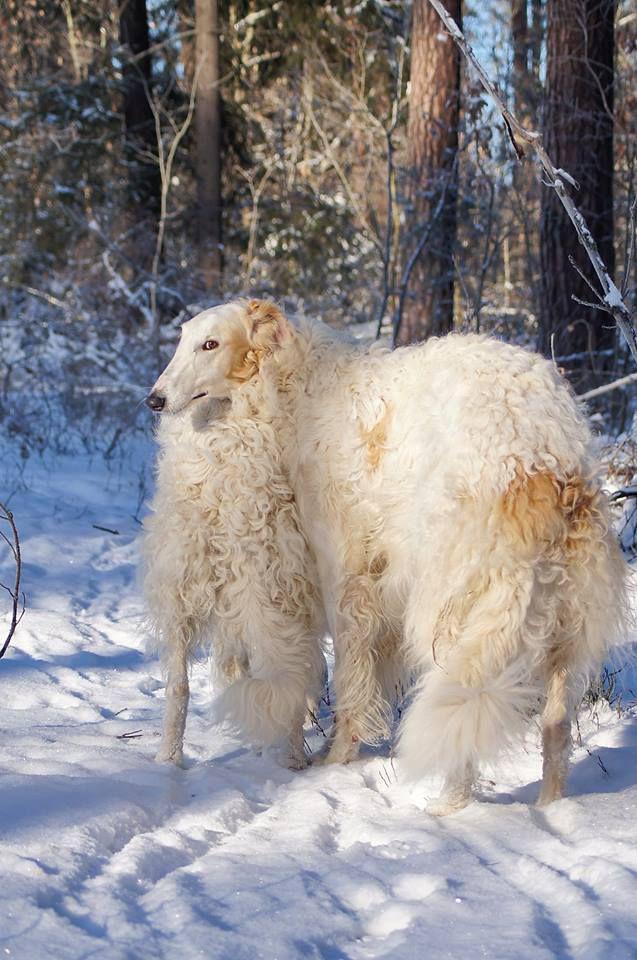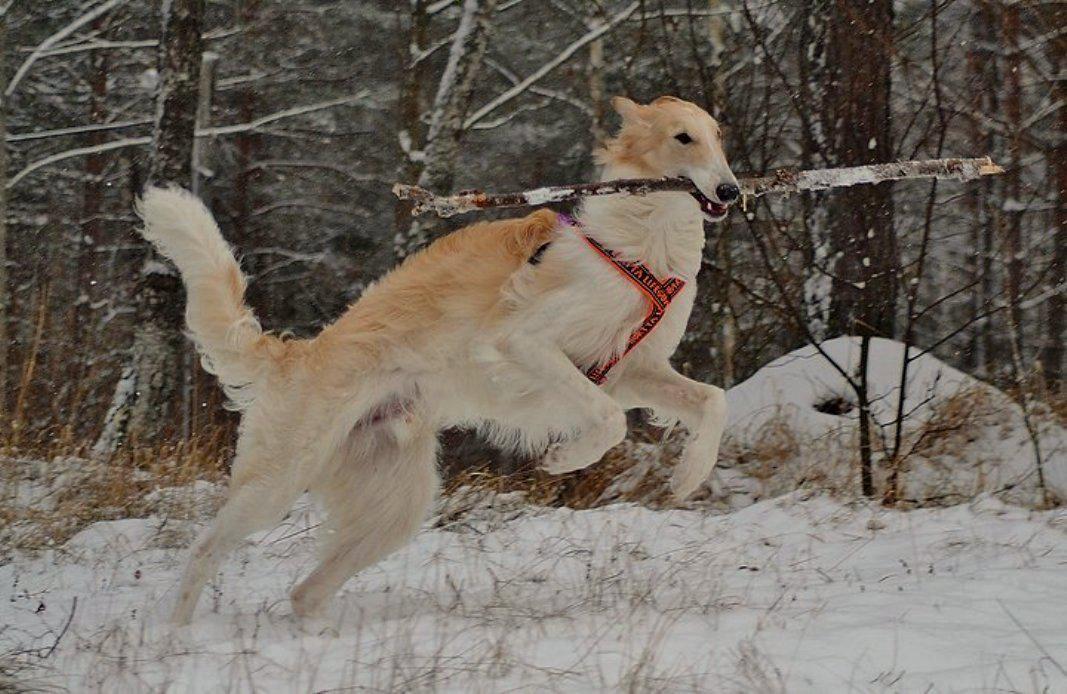The first image is the image on the left, the second image is the image on the right. Considering the images on both sides, is "One image is a wintry scene featuring a woman bundled up in a flowing garment with at least one hound on the left." valid? Answer yes or no. No. The first image is the image on the left, the second image is the image on the right. Assess this claim about the two images: "There are three dogs and a woman". Correct or not? Answer yes or no. No. 